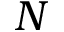<formula> <loc_0><loc_0><loc_500><loc_500>N</formula> 